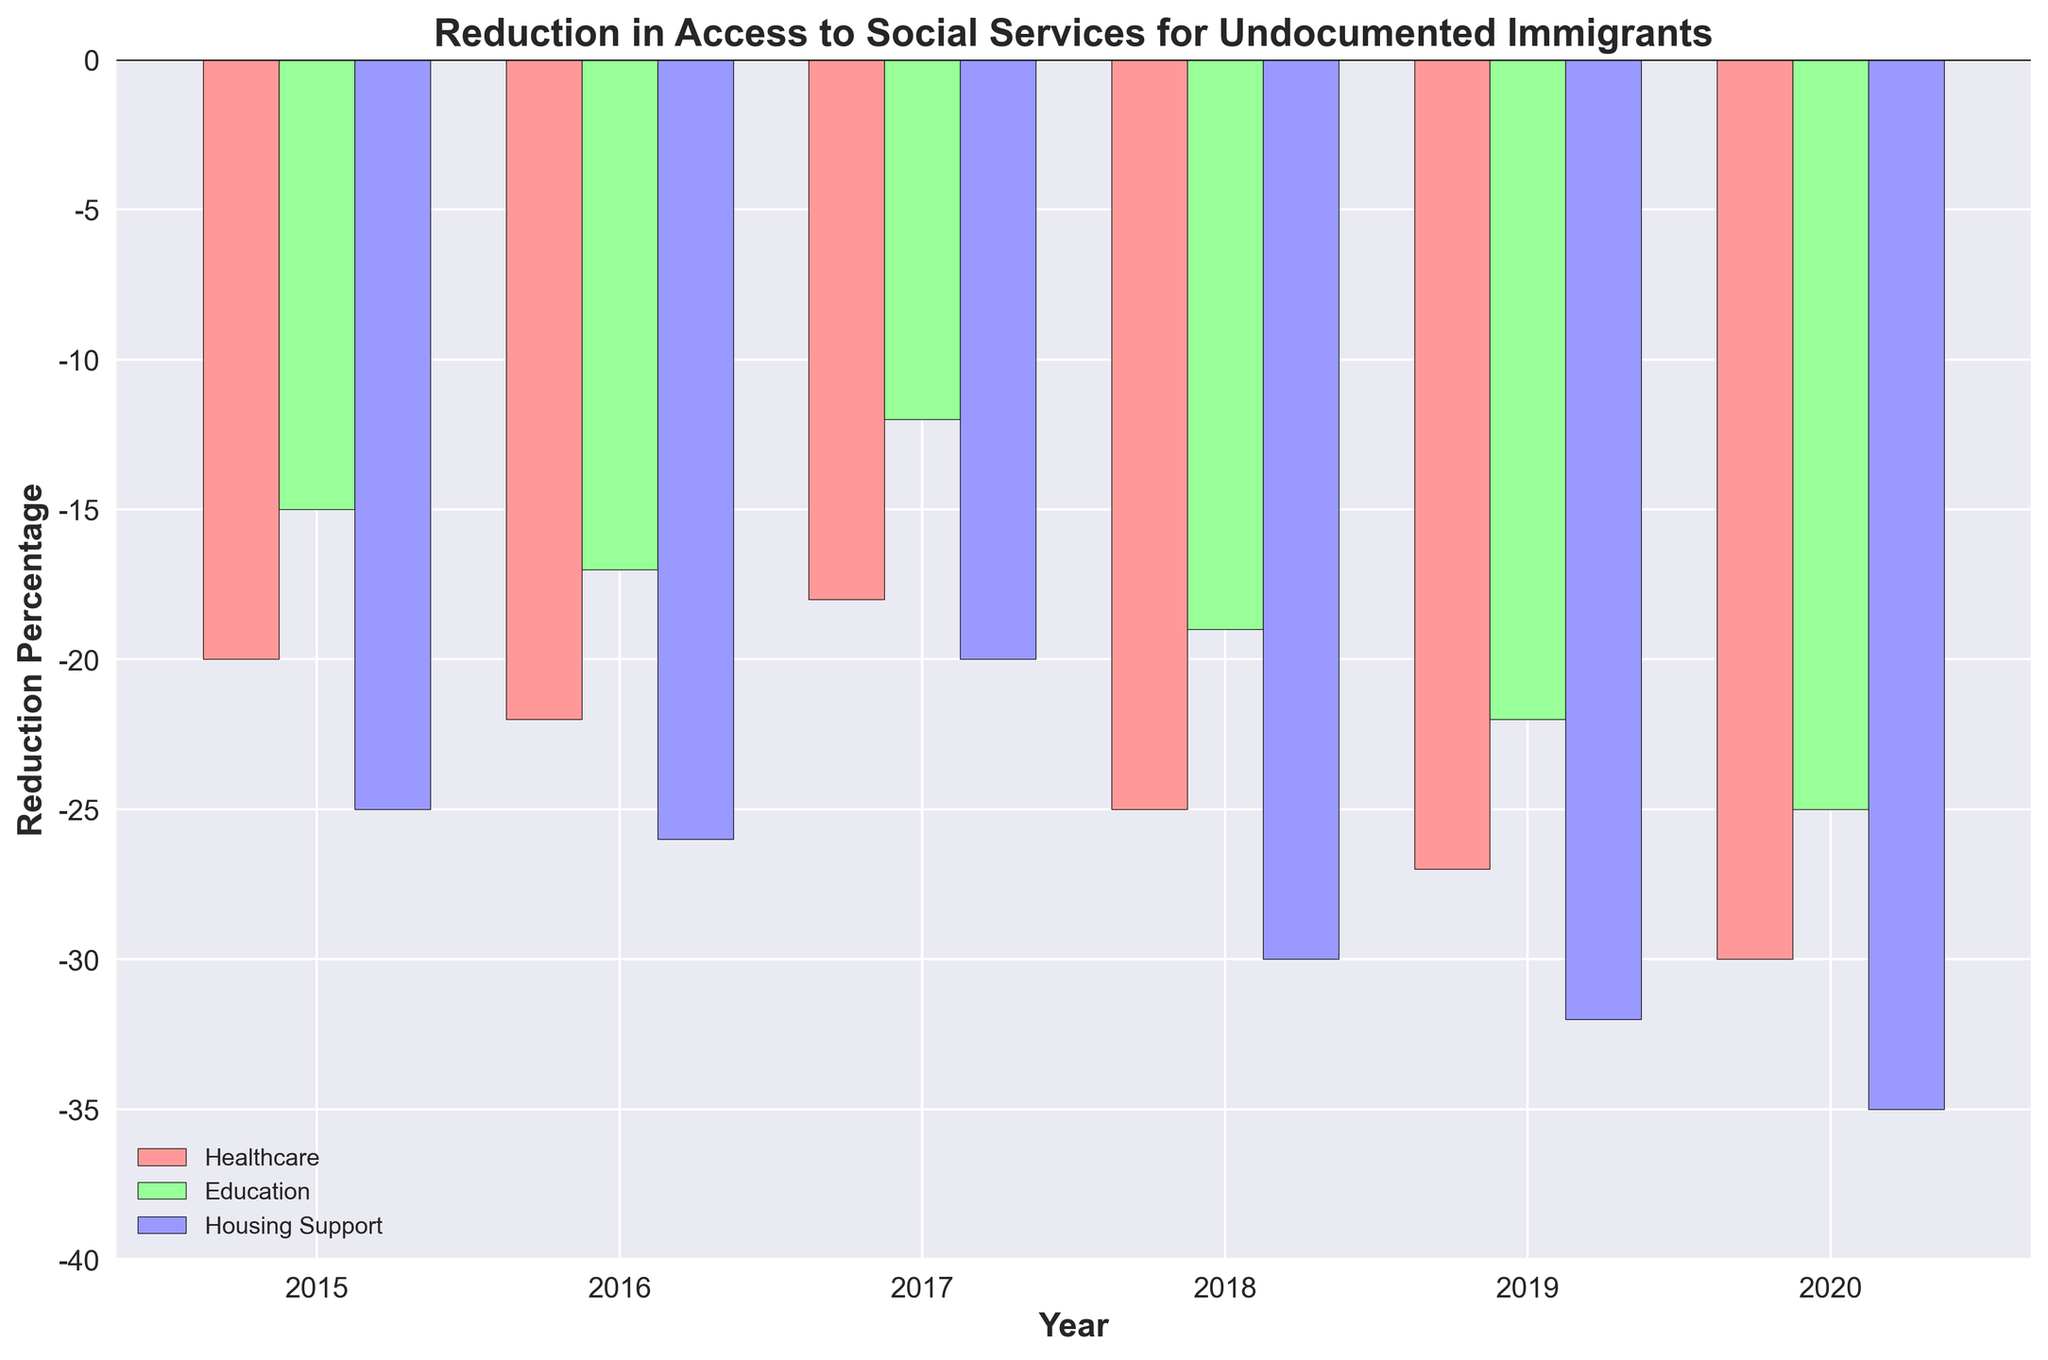What year saw the biggest reduction in access to healthcare services? The tallest bar in the healthcare section represents the largest negative percentage, which for healthcare is in 2020.
Answer: 2020 Which social service experienced the largest average reduction over the years? Calculate the average reduction for each service. Healthcare: (-20-22-18-25-27-30)/6 = -23.67, Education: (-15-17-12-19-22-25)/6 = -18.33, Housing Support: (-25-26-20-30-32-35)/6 = -28.
Answer: Housing Support What is the difference between the reduction in access to education services in 2015 and in 2020? In 2015, the reduction for education was -15%, and in 2020, it was -25%. The difference is -25 - (-15) = -10%.
Answer: -10% In which year was the reduction for housing support the lowest? Look for the tallest bar with the least negative value in the housing support section, which is in 2017.
Answer: 2017 Which social service had the smallest reduction in 2016, and what was the percentage? Compare the bars for different services in 2016. Education in 2016 had the smallest reduction at -17%.
Answer: Education, -17% What is the trend in reduction for education from 2015 to 2020? Observe the heights of the education bars from 2015 to 2020: -15, -17, -12, -19, -22, -25. The reduction generally increases, with a slight decrease in 2017.
Answer: Increasing trend Which year witnessed the smallest reduction in access to healthcare services? Among all healthcare bars, the one with the least negative value is in 2017, which shows -18%.
Answer: 2017 How does the reduction in housing support in 2018 compare to that in 2019? 2018 has a reduction of -30%, while 2019 has -32%. By comparing, -32% is more negative than -30%.
Answer: 2019 is larger How many types of social services are shown in the figure? Count the unique bars corresponding to each group: Healthcare, Education, Housing Support, totaling three types.
Answer: 3 Which year had the largest disparity between reductions for healthcare and education? Calculate the disparities for each year and find the year with the largest difference: 2015: 5, 2016: 5, 2017: 6, 2018: 6, 2019: 5, 2020: 5. The largest disparity is in 2017 and 2018 with a difference of 6.
Answer: 2017 and 2018 